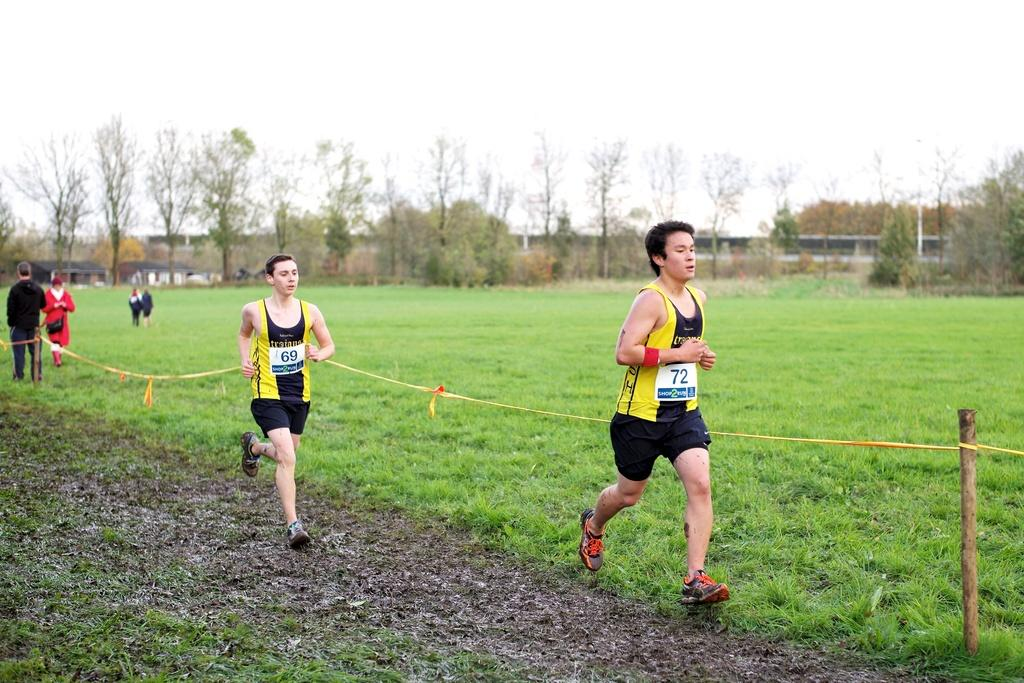<image>
Provide a brief description of the given image. two men that are jogging or running along a field, they are # 69 and # 72. 